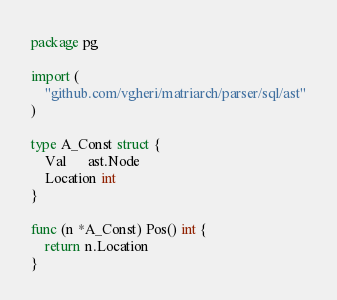Convert code to text. <code><loc_0><loc_0><loc_500><loc_500><_Go_>package pg

import (
	"github.com/vgheri/matriarch/parser/sql/ast"
)

type A_Const struct {
	Val      ast.Node
	Location int
}

func (n *A_Const) Pos() int {
	return n.Location
}
</code> 